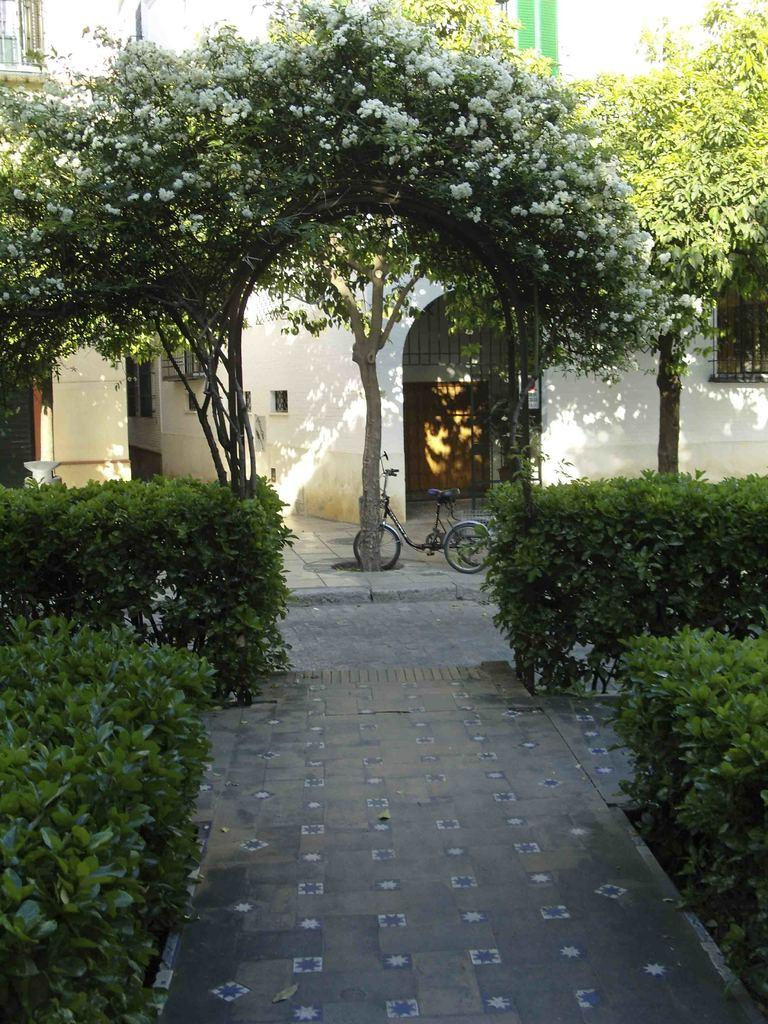What type of vegetation can be seen in the image? There are trees in the image. What mode of transportation is present in the image? There is a cycle in the image. What type of structures are visible in the image? There are buildings in the image. What is visible in the background of the image? The sky is visible in the image. What is the tendency of the quince to grow in the image? There is no quince present in the image, so it is not possible to determine its tendency to grow. How many members are in the group that can be seen in the image? There is no group of people present in the image; it features trees, a cycle, buildings, and the sky. 